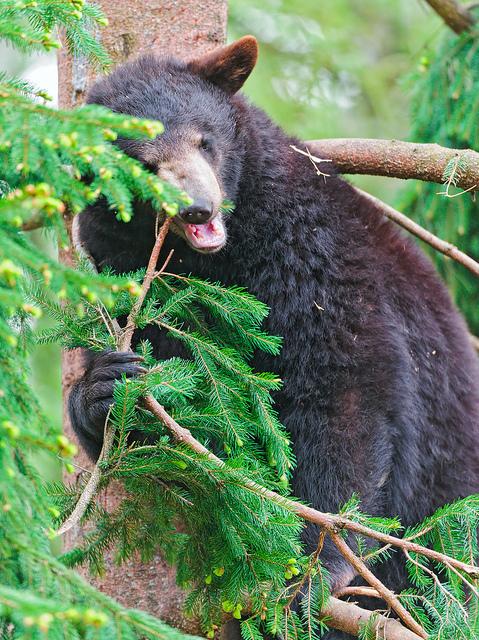Is the bear eating meat?
Give a very brief answer. No. What color bear is this?
Answer briefly. Black. What environment is this bear in?
Keep it brief. Forest. 